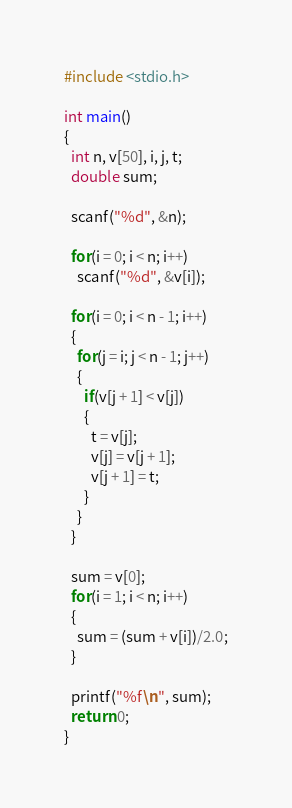Convert code to text. <code><loc_0><loc_0><loc_500><loc_500><_C_>#include <stdio.h>

int main()
{
  int n, v[50], i, j, t;
  double sum;
  
  scanf("%d", &n);
  
  for(i = 0; i < n; i++)
    scanf("%d", &v[i]);
  
  for(i = 0; i < n - 1; i++)
  {
    for(j = i; j < n - 1; j++)
    {
      if(v[j + 1] < v[j])
      {
        t = v[j];
        v[j] = v[j + 1];
        v[j + 1] = t;
      }
    }
  }
  
  sum = v[0];
  for(i = 1; i < n; i++)
  {
    sum = (sum + v[i])/2.0;
  }
  
  printf("%f\n", sum);
  return 0;
}</code> 